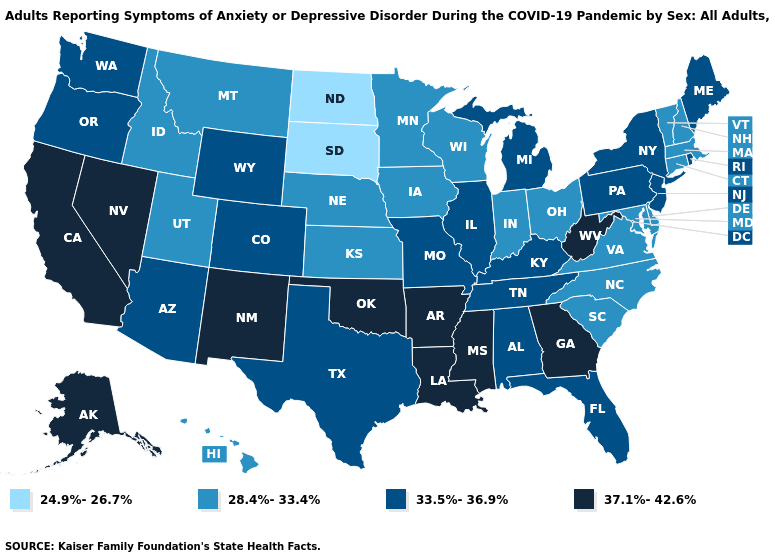Name the states that have a value in the range 28.4%-33.4%?
Short answer required. Connecticut, Delaware, Hawaii, Idaho, Indiana, Iowa, Kansas, Maryland, Massachusetts, Minnesota, Montana, Nebraska, New Hampshire, North Carolina, Ohio, South Carolina, Utah, Vermont, Virginia, Wisconsin. What is the highest value in states that border Arizona?
Short answer required. 37.1%-42.6%. Among the states that border Florida , which have the highest value?
Keep it brief. Georgia. Does Alaska have the lowest value in the USA?
Keep it brief. No. Does Montana have the lowest value in the West?
Answer briefly. Yes. What is the value of Oregon?
Be succinct. 33.5%-36.9%. What is the value of Texas?
Keep it brief. 33.5%-36.9%. What is the highest value in the USA?
Be succinct. 37.1%-42.6%. Among the states that border Illinois , does Kentucky have the highest value?
Short answer required. Yes. Name the states that have a value in the range 24.9%-26.7%?
Answer briefly. North Dakota, South Dakota. What is the lowest value in the West?
Short answer required. 28.4%-33.4%. Name the states that have a value in the range 28.4%-33.4%?
Keep it brief. Connecticut, Delaware, Hawaii, Idaho, Indiana, Iowa, Kansas, Maryland, Massachusetts, Minnesota, Montana, Nebraska, New Hampshire, North Carolina, Ohio, South Carolina, Utah, Vermont, Virginia, Wisconsin. How many symbols are there in the legend?
Write a very short answer. 4. What is the highest value in states that border Iowa?
Give a very brief answer. 33.5%-36.9%. Does Alabama have a lower value than Arkansas?
Answer briefly. Yes. 